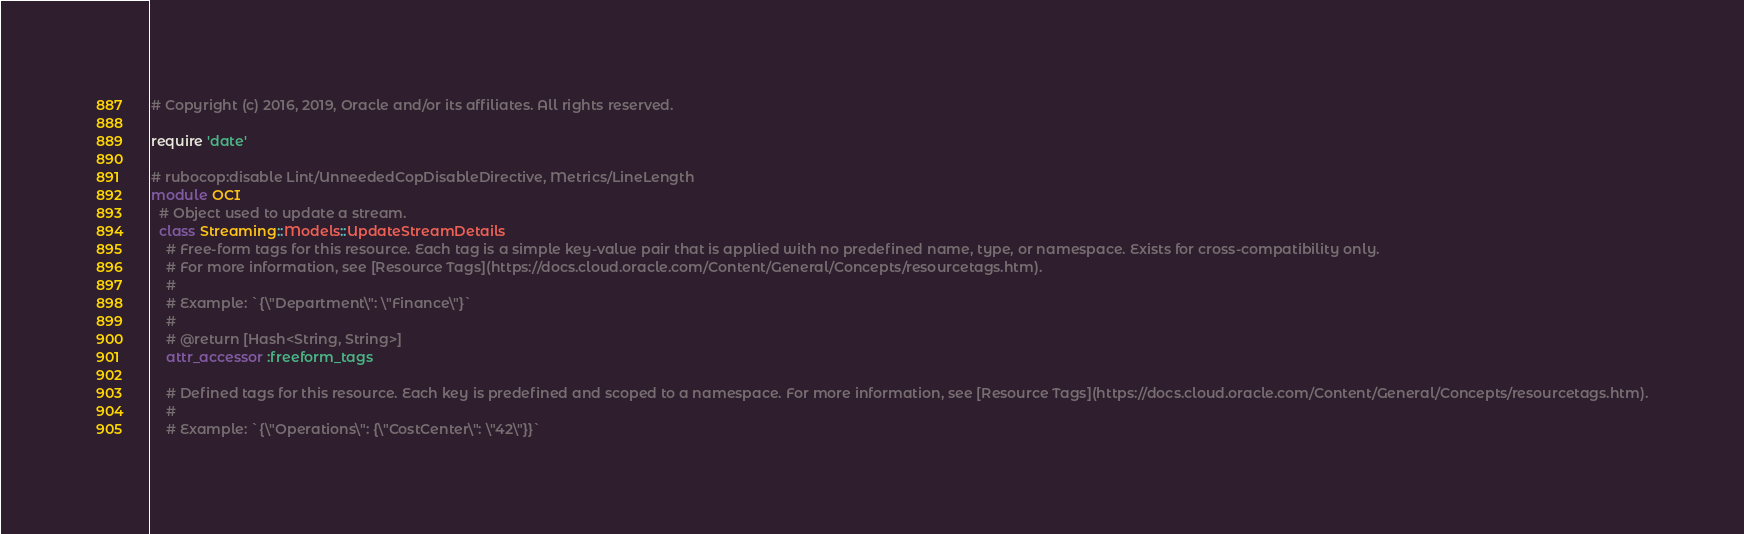<code> <loc_0><loc_0><loc_500><loc_500><_Ruby_># Copyright (c) 2016, 2019, Oracle and/or its affiliates. All rights reserved.

require 'date'

# rubocop:disable Lint/UnneededCopDisableDirective, Metrics/LineLength
module OCI
  # Object used to update a stream.
  class Streaming::Models::UpdateStreamDetails
    # Free-form tags for this resource. Each tag is a simple key-value pair that is applied with no predefined name, type, or namespace. Exists for cross-compatibility only.
    # For more information, see [Resource Tags](https://docs.cloud.oracle.com/Content/General/Concepts/resourcetags.htm).
    #
    # Example: `{\"Department\": \"Finance\"}`
    #
    # @return [Hash<String, String>]
    attr_accessor :freeform_tags

    # Defined tags for this resource. Each key is predefined and scoped to a namespace. For more information, see [Resource Tags](https://docs.cloud.oracle.com/Content/General/Concepts/resourcetags.htm).
    #
    # Example: `{\"Operations\": {\"CostCenter\": \"42\"}}`</code> 